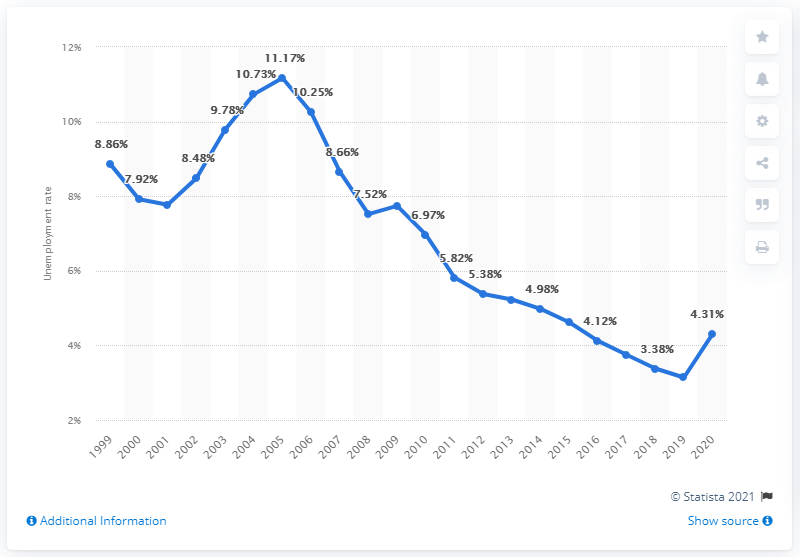Draw attention to some important aspects in this diagram. The unemployment rate in Germany in 2020 was 4.31%. 